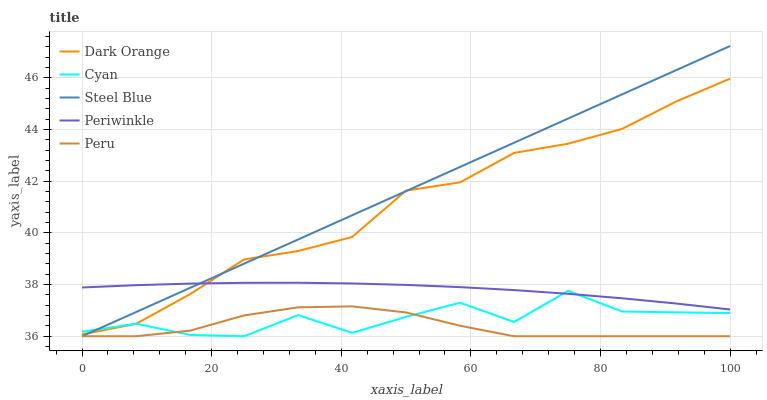Does Peru have the minimum area under the curve?
Answer yes or no. Yes. Does Steel Blue have the maximum area under the curve?
Answer yes or no. Yes. Does Periwinkle have the minimum area under the curve?
Answer yes or no. No. Does Periwinkle have the maximum area under the curve?
Answer yes or no. No. Is Steel Blue the smoothest?
Answer yes or no. Yes. Is Cyan the roughest?
Answer yes or no. Yes. Is Periwinkle the smoothest?
Answer yes or no. No. Is Periwinkle the roughest?
Answer yes or no. No. Does Steel Blue have the lowest value?
Answer yes or no. Yes. Does Periwinkle have the lowest value?
Answer yes or no. No. Does Steel Blue have the highest value?
Answer yes or no. Yes. Does Periwinkle have the highest value?
Answer yes or no. No. Is Peru less than Dark Orange?
Answer yes or no. Yes. Is Periwinkle greater than Peru?
Answer yes or no. Yes. Does Cyan intersect Dark Orange?
Answer yes or no. Yes. Is Cyan less than Dark Orange?
Answer yes or no. No. Is Cyan greater than Dark Orange?
Answer yes or no. No. Does Peru intersect Dark Orange?
Answer yes or no. No. 